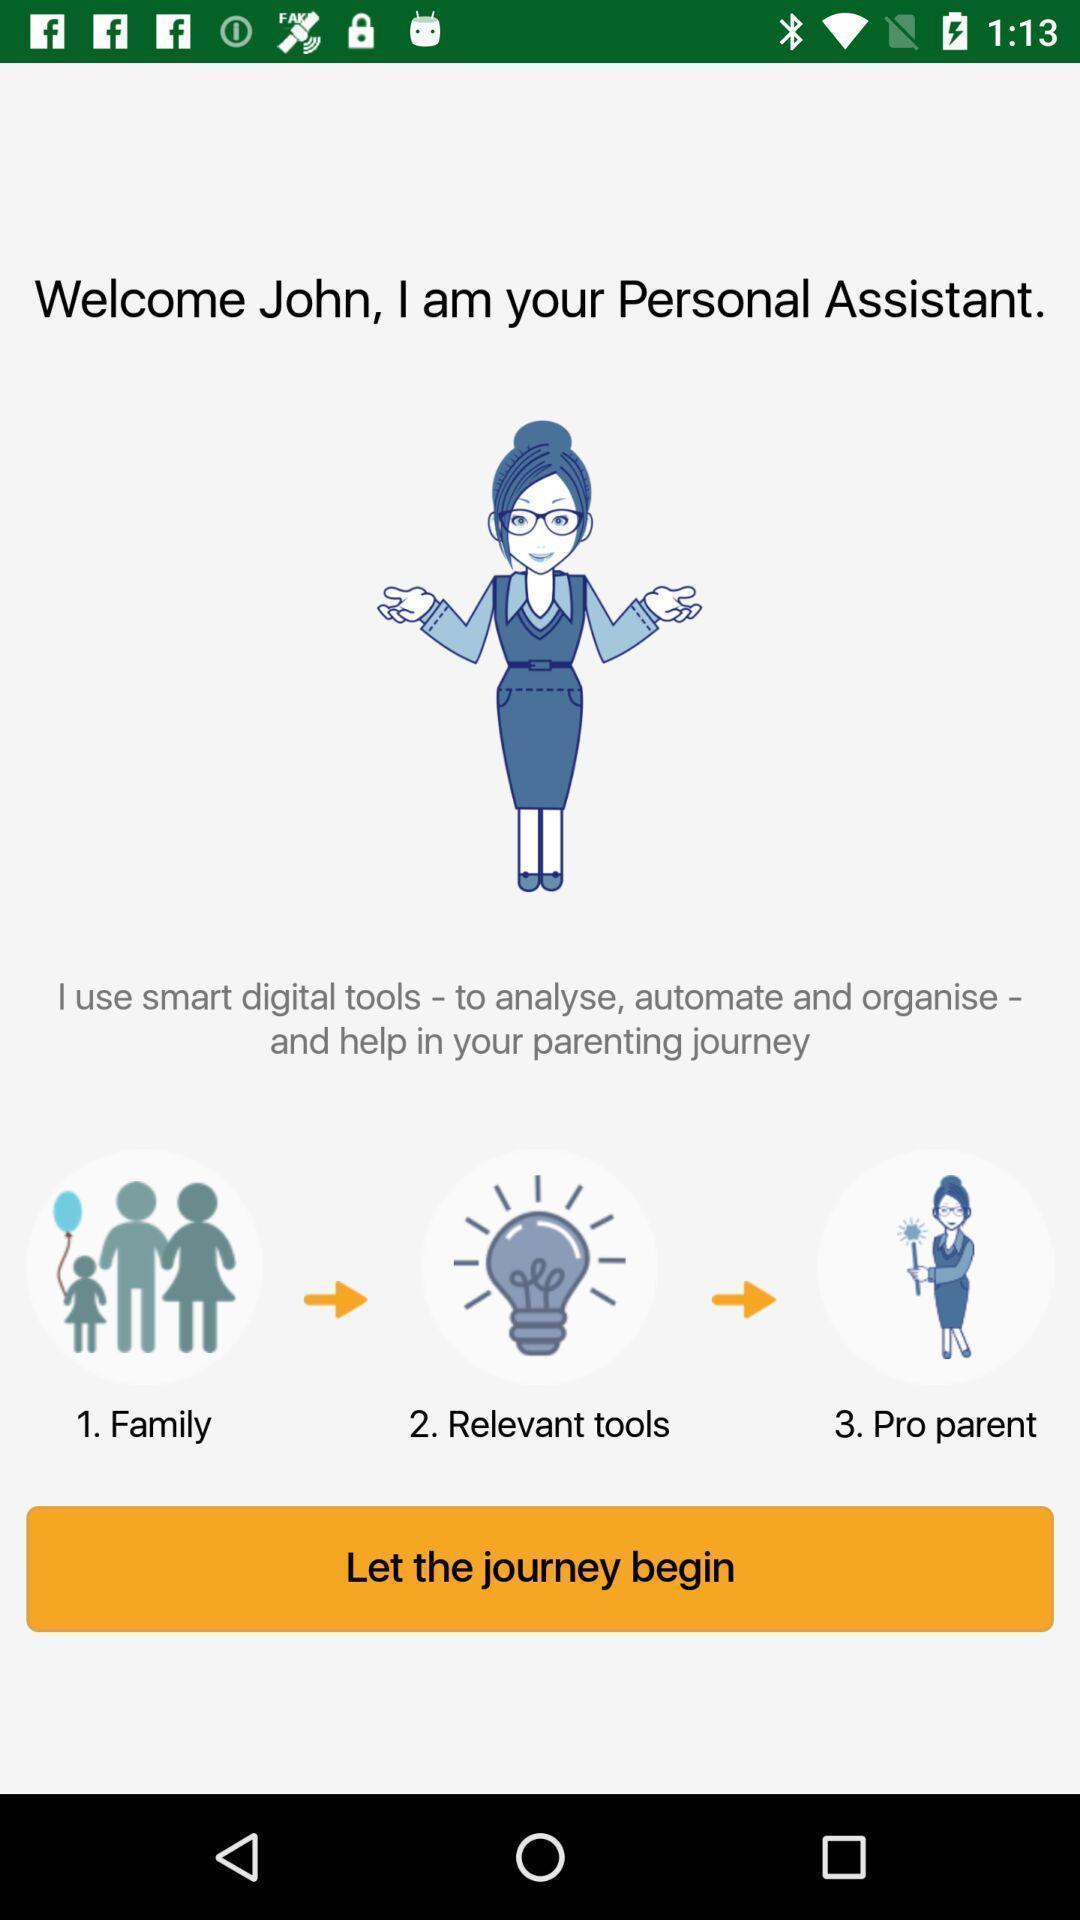Give me a summary of this screen capture. Welcome page. 